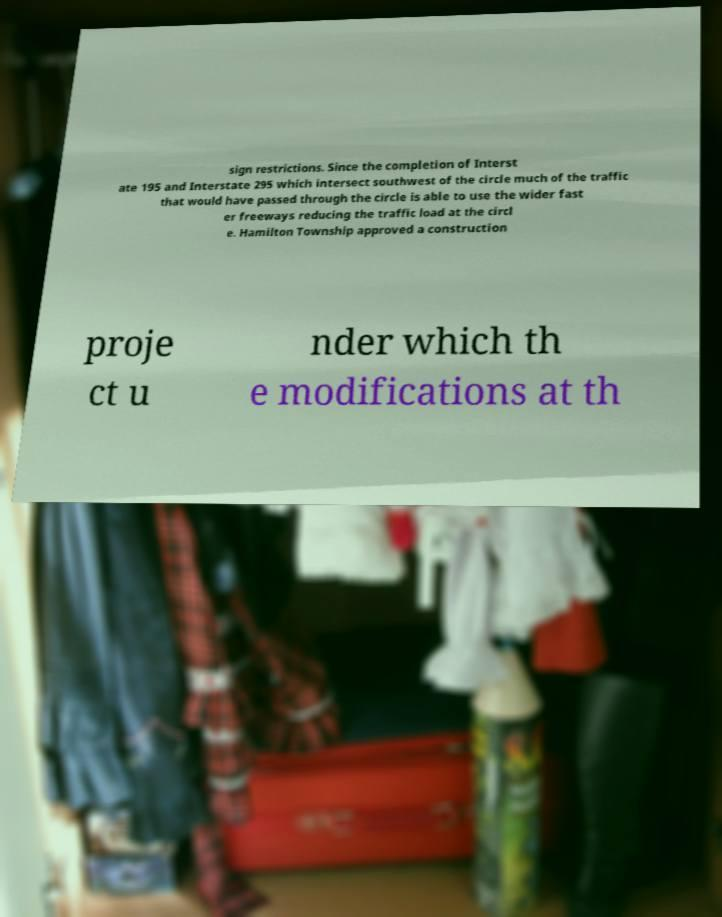Please read and relay the text visible in this image. What does it say? sign restrictions. Since the completion of Interst ate 195 and Interstate 295 which intersect southwest of the circle much of the traffic that would have passed through the circle is able to use the wider fast er freeways reducing the traffic load at the circl e. Hamilton Township approved a construction proje ct u nder which th e modifications at th 